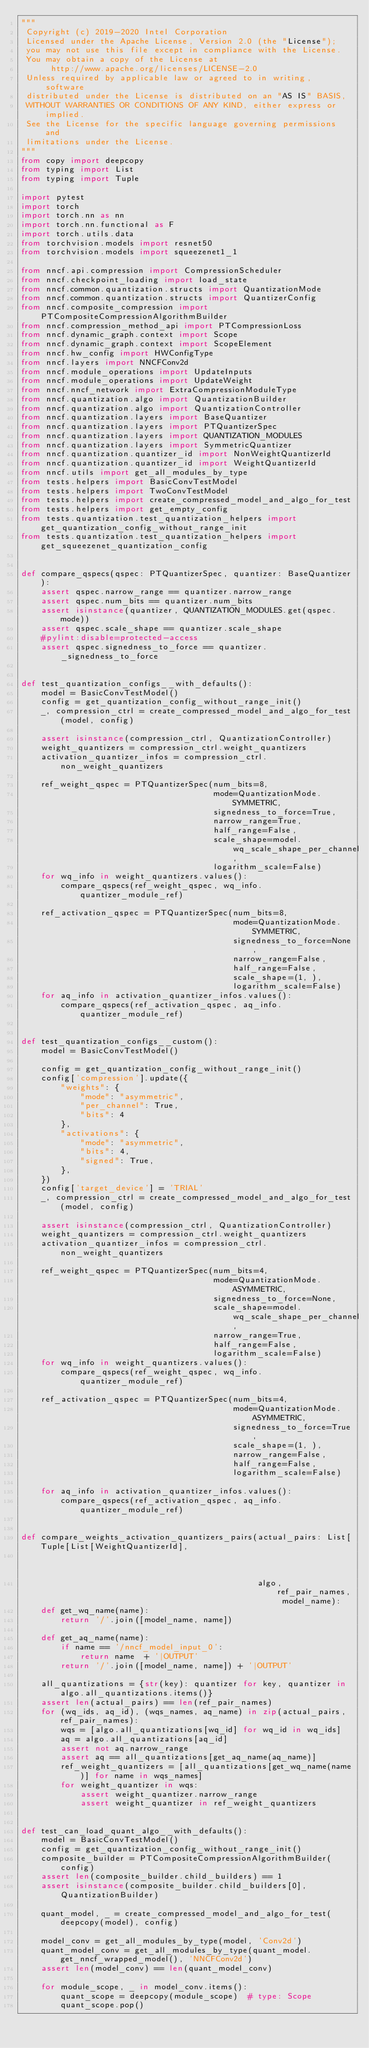<code> <loc_0><loc_0><loc_500><loc_500><_Python_>"""
 Copyright (c) 2019-2020 Intel Corporation
 Licensed under the Apache License, Version 2.0 (the "License");
 you may not use this file except in compliance with the License.
 You may obtain a copy of the License at
      http://www.apache.org/licenses/LICENSE-2.0
 Unless required by applicable law or agreed to in writing, software
 distributed under the License is distributed on an "AS IS" BASIS,
 WITHOUT WARRANTIES OR CONDITIONS OF ANY KIND, either express or implied.
 See the License for the specific language governing permissions and
 limitations under the License.
"""
from copy import deepcopy
from typing import List
from typing import Tuple

import pytest
import torch
import torch.nn as nn
import torch.nn.functional as F
import torch.utils.data
from torchvision.models import resnet50
from torchvision.models import squeezenet1_1

from nncf.api.compression import CompressionScheduler
from nncf.checkpoint_loading import load_state
from nncf.common.quantization.structs import QuantizationMode
from nncf.common.quantization.structs import QuantizerConfig
from nncf.composite_compression import PTCompositeCompressionAlgorithmBuilder
from nncf.compression_method_api import PTCompressionLoss
from nncf.dynamic_graph.context import Scope
from nncf.dynamic_graph.context import ScopeElement
from nncf.hw_config import HWConfigType
from nncf.layers import NNCFConv2d
from nncf.module_operations import UpdateInputs
from nncf.module_operations import UpdateWeight
from nncf.nncf_network import ExtraCompressionModuleType
from nncf.quantization.algo import QuantizationBuilder
from nncf.quantization.algo import QuantizationController
from nncf.quantization.layers import BaseQuantizer
from nncf.quantization.layers import PTQuantizerSpec
from nncf.quantization.layers import QUANTIZATION_MODULES
from nncf.quantization.layers import SymmetricQuantizer
from nncf.quantization.quantizer_id import NonWeightQuantizerId
from nncf.quantization.quantizer_id import WeightQuantizerId
from nncf.utils import get_all_modules_by_type
from tests.helpers import BasicConvTestModel
from tests.helpers import TwoConvTestModel
from tests.helpers import create_compressed_model_and_algo_for_test
from tests.helpers import get_empty_config
from tests.quantization.test_quantization_helpers import get_quantization_config_without_range_init
from tests.quantization.test_quantization_helpers import get_squeezenet_quantization_config


def compare_qspecs(qspec: PTQuantizerSpec, quantizer: BaseQuantizer):
    assert qspec.narrow_range == quantizer.narrow_range
    assert qspec.num_bits == quantizer.num_bits
    assert isinstance(quantizer, QUANTIZATION_MODULES.get(qspec.mode))
    assert qspec.scale_shape == quantizer.scale_shape
    #pylint:disable=protected-access
    assert qspec.signedness_to_force == quantizer._signedness_to_force


def test_quantization_configs__with_defaults():
    model = BasicConvTestModel()
    config = get_quantization_config_without_range_init()
    _, compression_ctrl = create_compressed_model_and_algo_for_test(model, config)

    assert isinstance(compression_ctrl, QuantizationController)
    weight_quantizers = compression_ctrl.weight_quantizers
    activation_quantizer_infos = compression_ctrl.non_weight_quantizers

    ref_weight_qspec = PTQuantizerSpec(num_bits=8,
                                       mode=QuantizationMode.SYMMETRIC,
                                       signedness_to_force=True,
                                       narrow_range=True,
                                       half_range=False,
                                       scale_shape=model.wq_scale_shape_per_channel,
                                       logarithm_scale=False)
    for wq_info in weight_quantizers.values():
        compare_qspecs(ref_weight_qspec, wq_info.quantizer_module_ref)

    ref_activation_qspec = PTQuantizerSpec(num_bits=8,
                                           mode=QuantizationMode.SYMMETRIC,
                                           signedness_to_force=None,
                                           narrow_range=False,
                                           half_range=False,
                                           scale_shape=(1, ),
                                           logarithm_scale=False)
    for aq_info in activation_quantizer_infos.values():
        compare_qspecs(ref_activation_qspec, aq_info.quantizer_module_ref)


def test_quantization_configs__custom():
    model = BasicConvTestModel()

    config = get_quantization_config_without_range_init()
    config['compression'].update({
        "weights": {
            "mode": "asymmetric",
            "per_channel": True,
            "bits": 4
        },
        "activations": {
            "mode": "asymmetric",
            "bits": 4,
            "signed": True,
        },
    })
    config['target_device'] = 'TRIAL'
    _, compression_ctrl = create_compressed_model_and_algo_for_test(model, config)

    assert isinstance(compression_ctrl, QuantizationController)
    weight_quantizers = compression_ctrl.weight_quantizers
    activation_quantizer_infos = compression_ctrl.non_weight_quantizers

    ref_weight_qspec = PTQuantizerSpec(num_bits=4,
                                       mode=QuantizationMode.ASYMMETRIC,
                                       signedness_to_force=None,
                                       scale_shape=model.wq_scale_shape_per_channel,
                                       narrow_range=True,
                                       half_range=False,
                                       logarithm_scale=False)
    for wq_info in weight_quantizers.values():
        compare_qspecs(ref_weight_qspec, wq_info.quantizer_module_ref)

    ref_activation_qspec = PTQuantizerSpec(num_bits=4,
                                           mode=QuantizationMode.ASYMMETRIC,
                                           signedness_to_force=True,
                                           scale_shape=(1, ),
                                           narrow_range=False,
                                           half_range=False,
                                           logarithm_scale=False)

    for aq_info in activation_quantizer_infos.values():
        compare_qspecs(ref_activation_qspec, aq_info.quantizer_module_ref)


def compare_weights_activation_quantizers_pairs(actual_pairs: List[Tuple[List[WeightQuantizerId],
                                                                         NonWeightQuantizerId]],
                                                algo, ref_pair_names, model_name):
    def get_wq_name(name):
        return '/'.join([model_name, name])

    def get_aq_name(name):
        if name == '/nncf_model_input_0':
            return name  + '|OUTPUT'
        return '/'.join([model_name, name]) + '|OUTPUT'

    all_quantizations = {str(key): quantizer for key, quantizer in algo.all_quantizations.items()}
    assert len(actual_pairs) == len(ref_pair_names)
    for (wq_ids, aq_id), (wqs_names, aq_name) in zip(actual_pairs, ref_pair_names):
        wqs = [algo.all_quantizations[wq_id] for wq_id in wq_ids]
        aq = algo.all_quantizations[aq_id]
        assert not aq.narrow_range
        assert aq == all_quantizations[get_aq_name(aq_name)]
        ref_weight_quantizers = [all_quantizations[get_wq_name(name)] for name in wqs_names]
        for weight_quantizer in wqs:
            assert weight_quantizer.narrow_range
            assert weight_quantizer in ref_weight_quantizers


def test_can_load_quant_algo__with_defaults():
    model = BasicConvTestModel()
    config = get_quantization_config_without_range_init()
    composite_builder = PTCompositeCompressionAlgorithmBuilder(config)
    assert len(composite_builder.child_builders) == 1
    assert isinstance(composite_builder.child_builders[0], QuantizationBuilder)

    quant_model, _ = create_compressed_model_and_algo_for_test(deepcopy(model), config)

    model_conv = get_all_modules_by_type(model, 'Conv2d')
    quant_model_conv = get_all_modules_by_type(quant_model.get_nncf_wrapped_model(), 'NNCFConv2d')
    assert len(model_conv) == len(quant_model_conv)

    for module_scope, _ in model_conv.items():
        quant_scope = deepcopy(module_scope)  # type: Scope
        quant_scope.pop()</code> 